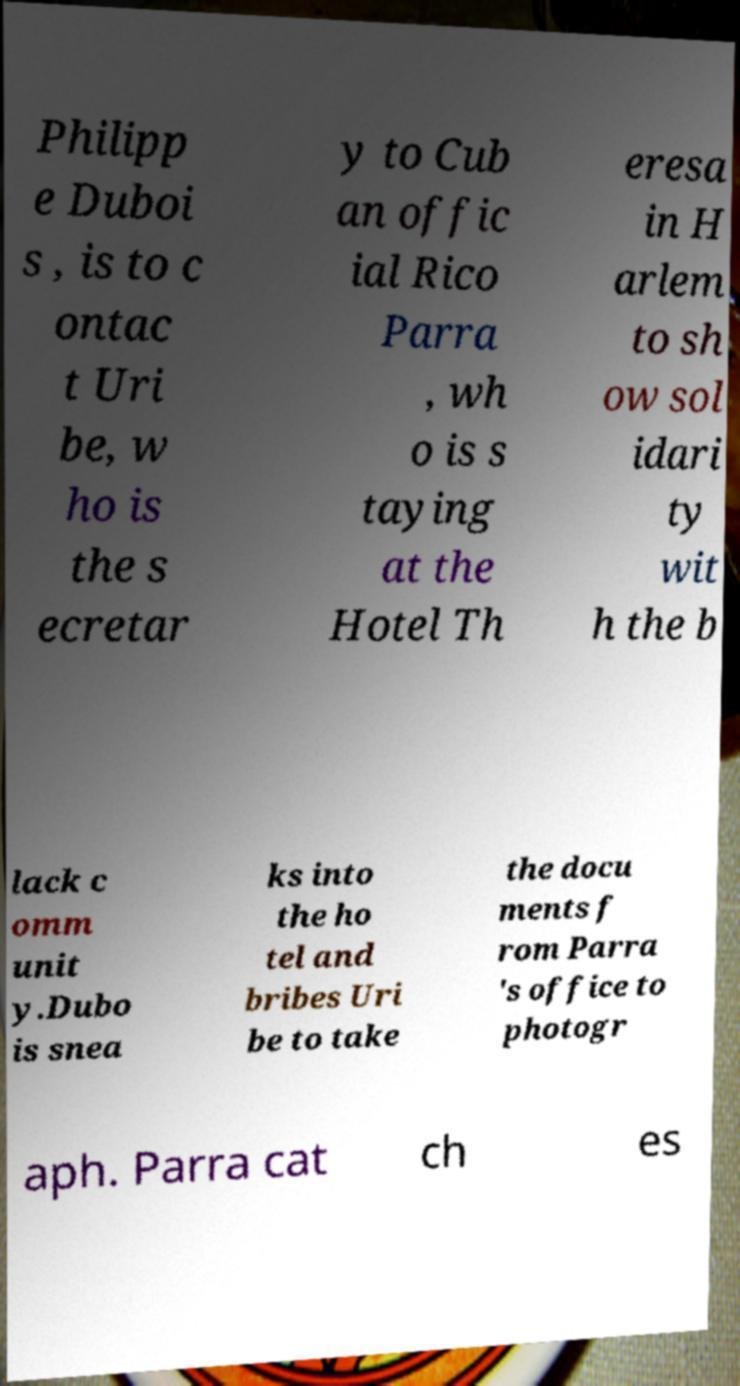What messages or text are displayed in this image? I need them in a readable, typed format. Philipp e Duboi s , is to c ontac t Uri be, w ho is the s ecretar y to Cub an offic ial Rico Parra , wh o is s taying at the Hotel Th eresa in H arlem to sh ow sol idari ty wit h the b lack c omm unit y.Dubo is snea ks into the ho tel and bribes Uri be to take the docu ments f rom Parra 's office to photogr aph. Parra cat ch es 